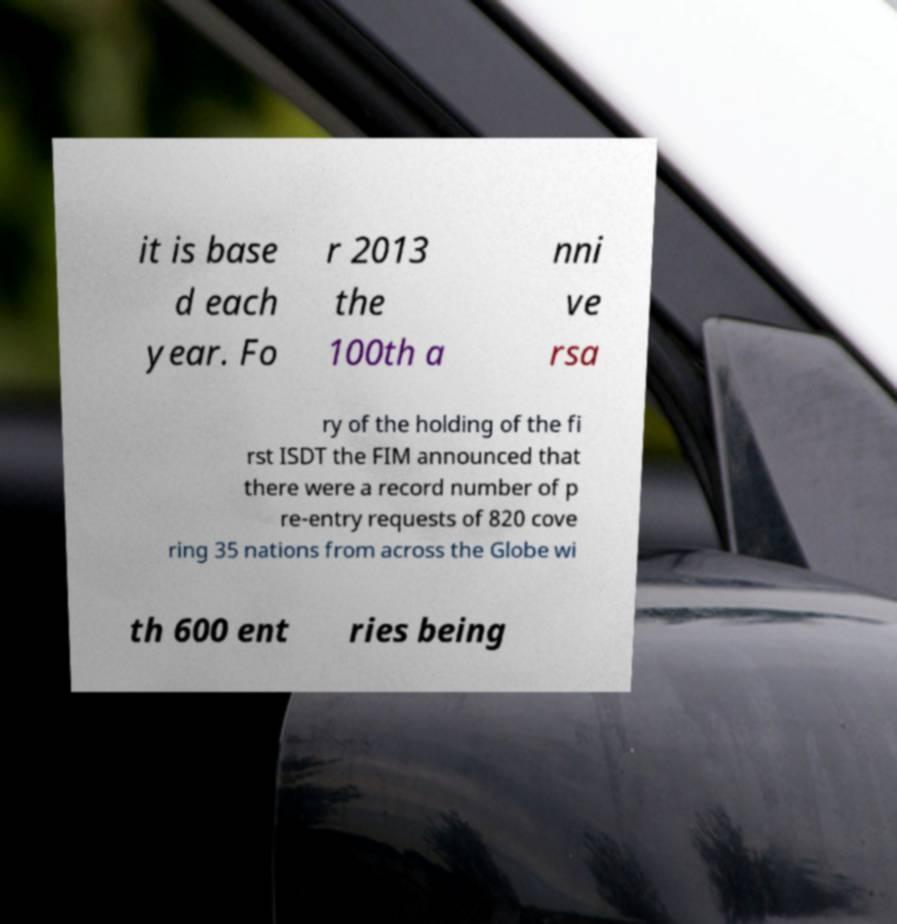I need the written content from this picture converted into text. Can you do that? it is base d each year. Fo r 2013 the 100th a nni ve rsa ry of the holding of the fi rst ISDT the FIM announced that there were a record number of p re-entry requests of 820 cove ring 35 nations from across the Globe wi th 600 ent ries being 